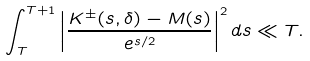<formula> <loc_0><loc_0><loc_500><loc_500>\int _ { T } ^ { T + 1 } \left | \frac { K ^ { \pm } ( s , \delta ) - M ( s ) } { e ^ { s / 2 } } \right | ^ { 2 } d s \ll T .</formula> 